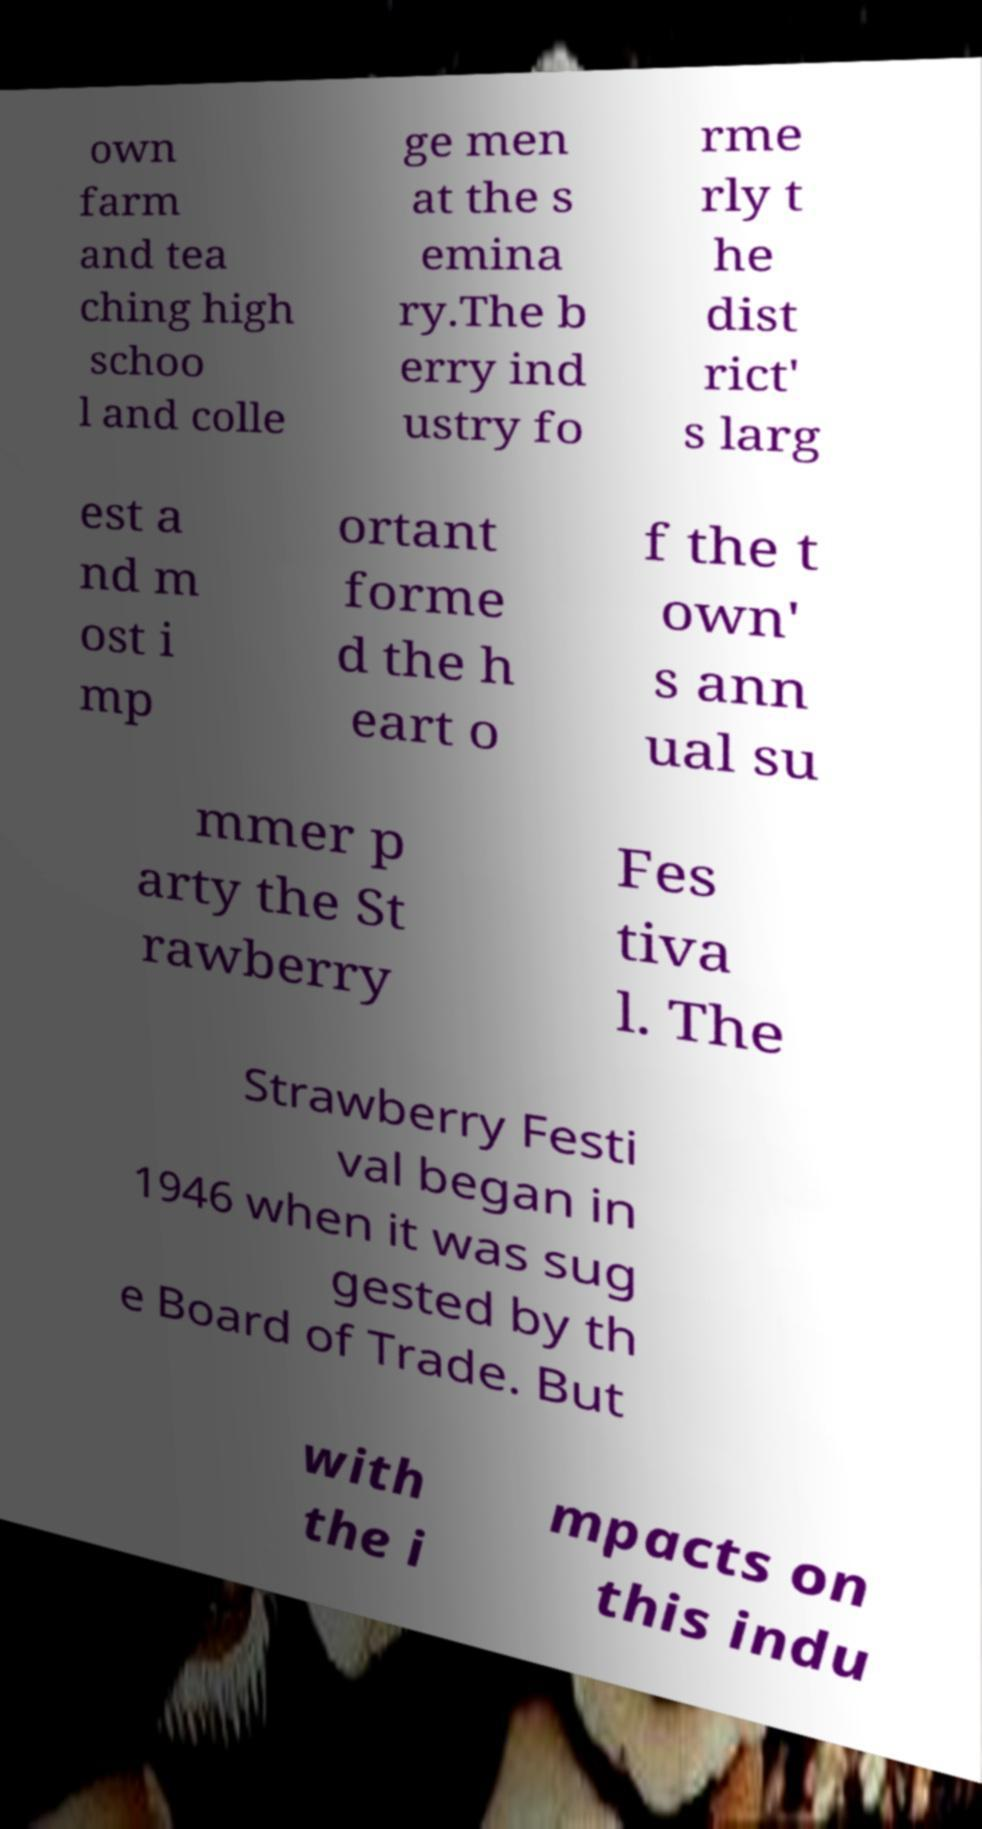Can you read and provide the text displayed in the image?This photo seems to have some interesting text. Can you extract and type it out for me? own farm and tea ching high schoo l and colle ge men at the s emina ry.The b erry ind ustry fo rme rly t he dist rict' s larg est a nd m ost i mp ortant forme d the h eart o f the t own' s ann ual su mmer p arty the St rawberry Fes tiva l. The Strawberry Festi val began in 1946 when it was sug gested by th e Board of Trade. But with the i mpacts on this indu 